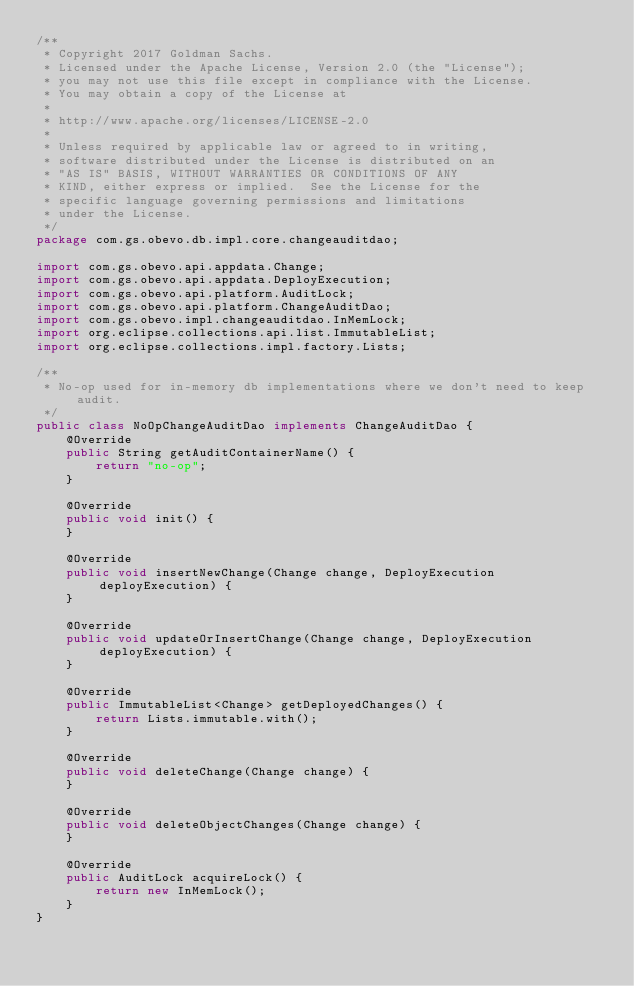<code> <loc_0><loc_0><loc_500><loc_500><_Java_>/**
 * Copyright 2017 Goldman Sachs.
 * Licensed under the Apache License, Version 2.0 (the "License");
 * you may not use this file except in compliance with the License.
 * You may obtain a copy of the License at
 *
 * http://www.apache.org/licenses/LICENSE-2.0
 *
 * Unless required by applicable law or agreed to in writing,
 * software distributed under the License is distributed on an
 * "AS IS" BASIS, WITHOUT WARRANTIES OR CONDITIONS OF ANY
 * KIND, either express or implied.  See the License for the
 * specific language governing permissions and limitations
 * under the License.
 */
package com.gs.obevo.db.impl.core.changeauditdao;

import com.gs.obevo.api.appdata.Change;
import com.gs.obevo.api.appdata.DeployExecution;
import com.gs.obevo.api.platform.AuditLock;
import com.gs.obevo.api.platform.ChangeAuditDao;
import com.gs.obevo.impl.changeauditdao.InMemLock;
import org.eclipse.collections.api.list.ImmutableList;
import org.eclipse.collections.impl.factory.Lists;

/**
 * No-op used for in-memory db implementations where we don't need to keep audit.
 */
public class NoOpChangeAuditDao implements ChangeAuditDao {
    @Override
    public String getAuditContainerName() {
        return "no-op";
    }

    @Override
    public void init() {
    }

    @Override
    public void insertNewChange(Change change, DeployExecution deployExecution) {
    }

    @Override
    public void updateOrInsertChange(Change change, DeployExecution deployExecution) {
    }

    @Override
    public ImmutableList<Change> getDeployedChanges() {
        return Lists.immutable.with();
    }

    @Override
    public void deleteChange(Change change) {
    }

    @Override
    public void deleteObjectChanges(Change change) {
    }

    @Override
    public AuditLock acquireLock() {
        return new InMemLock();
    }
}
</code> 